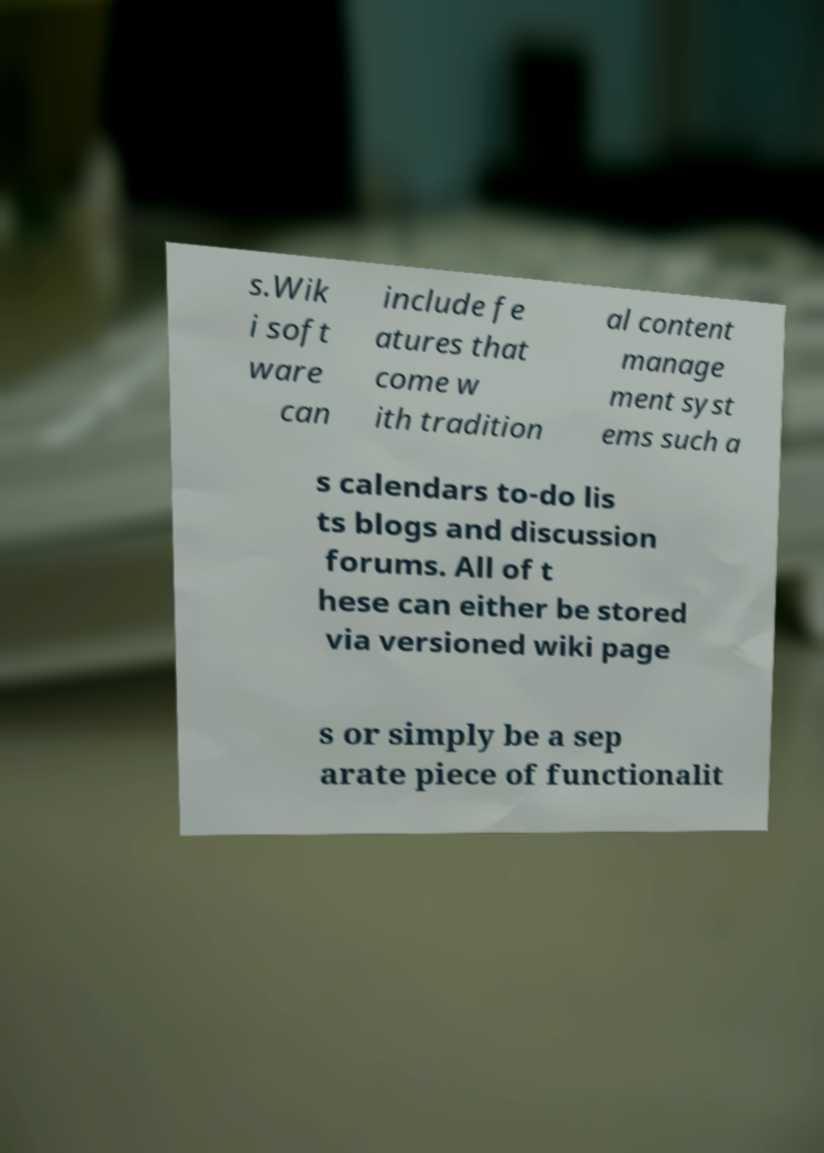For documentation purposes, I need the text within this image transcribed. Could you provide that? s.Wik i soft ware can include fe atures that come w ith tradition al content manage ment syst ems such a s calendars to-do lis ts blogs and discussion forums. All of t hese can either be stored via versioned wiki page s or simply be a sep arate piece of functionalit 